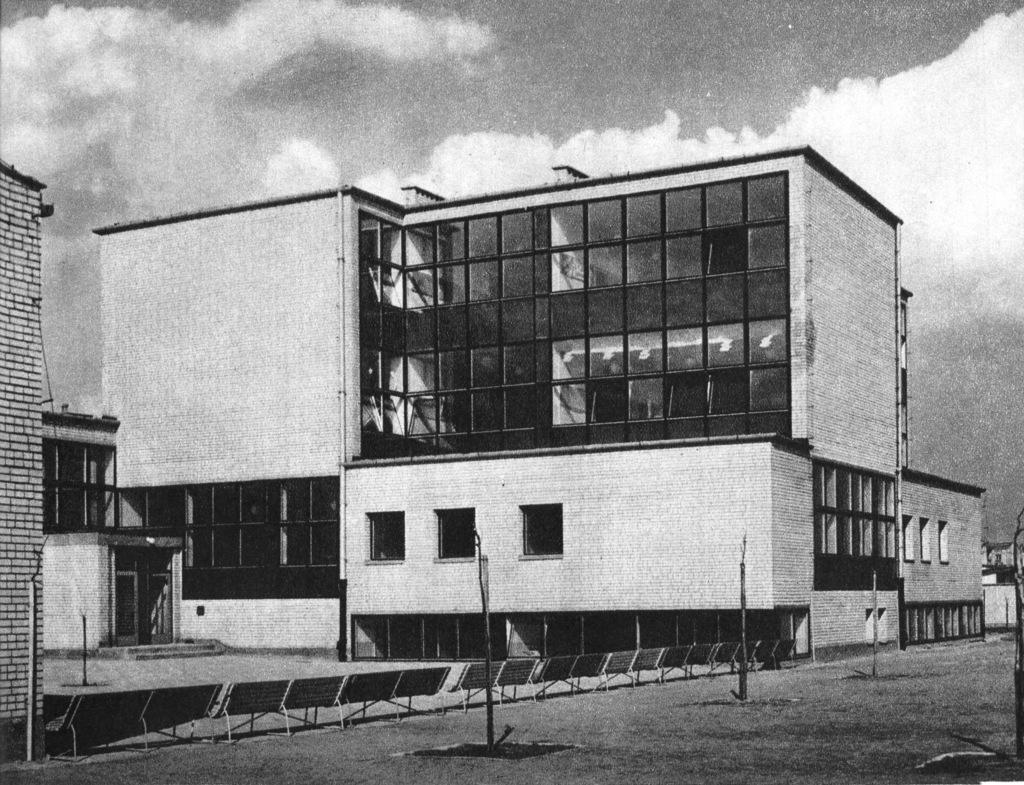What is the color scheme of the image? The image is black and white. What structures can be seen on the land in the image? There are poles on the land in the image. What type of seating is available in the image? There are benches in the image. What can be seen in the background of the image? There are buildings in the background of the image. What is visible at the top of the image? The sky is visible at the top of the image. What can be observed in the sky? There are clouds in the sky. Where is the window located in the image? There is no window present in the image. What type of coil is used to heat the sink in the image? There is no sink or coil present in the image. 